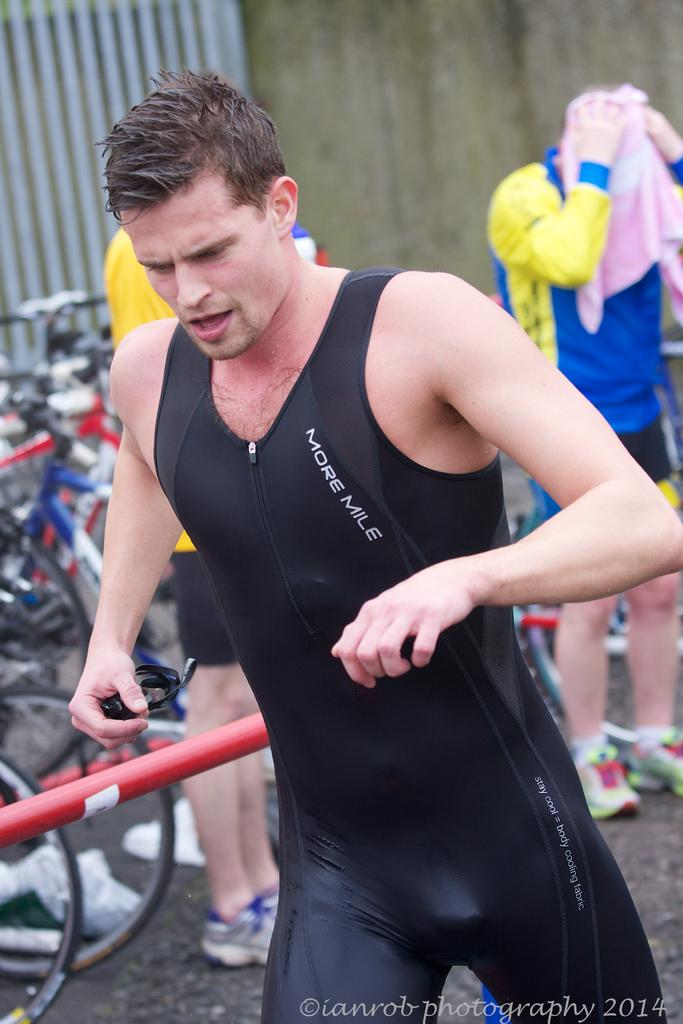Who is present in the image? There is a man in the image. What is the man wearing? The man is wearing a black dress. What can be seen in the background of the image? There are cycles in the background of the image. How many other people are present in the image? There are 2 men standing in the background of the image. What type of bed can be seen in the image? There is no bed present in the image. How many stars are visible in the image? There are no stars visible in the image. 